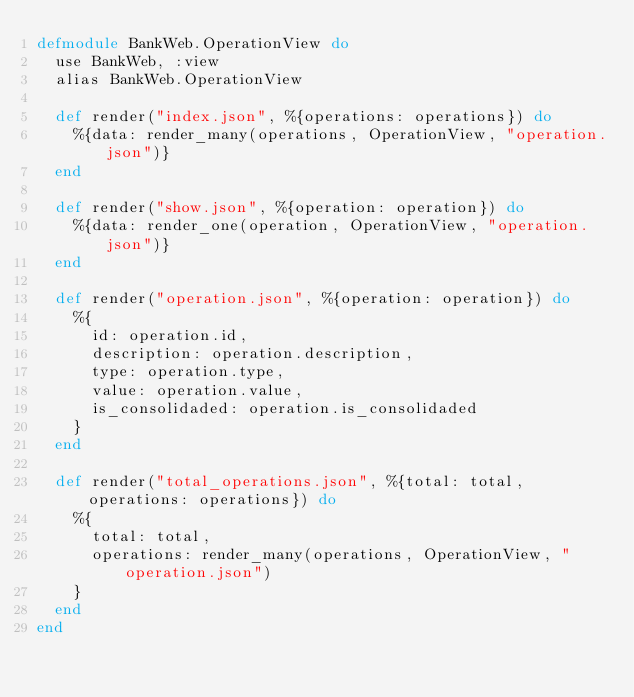Convert code to text. <code><loc_0><loc_0><loc_500><loc_500><_Elixir_>defmodule BankWeb.OperationView do
  use BankWeb, :view
  alias BankWeb.OperationView

  def render("index.json", %{operations: operations}) do
    %{data: render_many(operations, OperationView, "operation.json")}
  end

  def render("show.json", %{operation: operation}) do
    %{data: render_one(operation, OperationView, "operation.json")}
  end

  def render("operation.json", %{operation: operation}) do
    %{
      id: operation.id,
      description: operation.description,
      type: operation.type,
      value: operation.value,
      is_consolidaded: operation.is_consolidaded
    }
  end

  def render("total_operations.json", %{total: total, operations: operations}) do
    %{
      total: total,
      operations: render_many(operations, OperationView, "operation.json")
    }
  end
end
</code> 